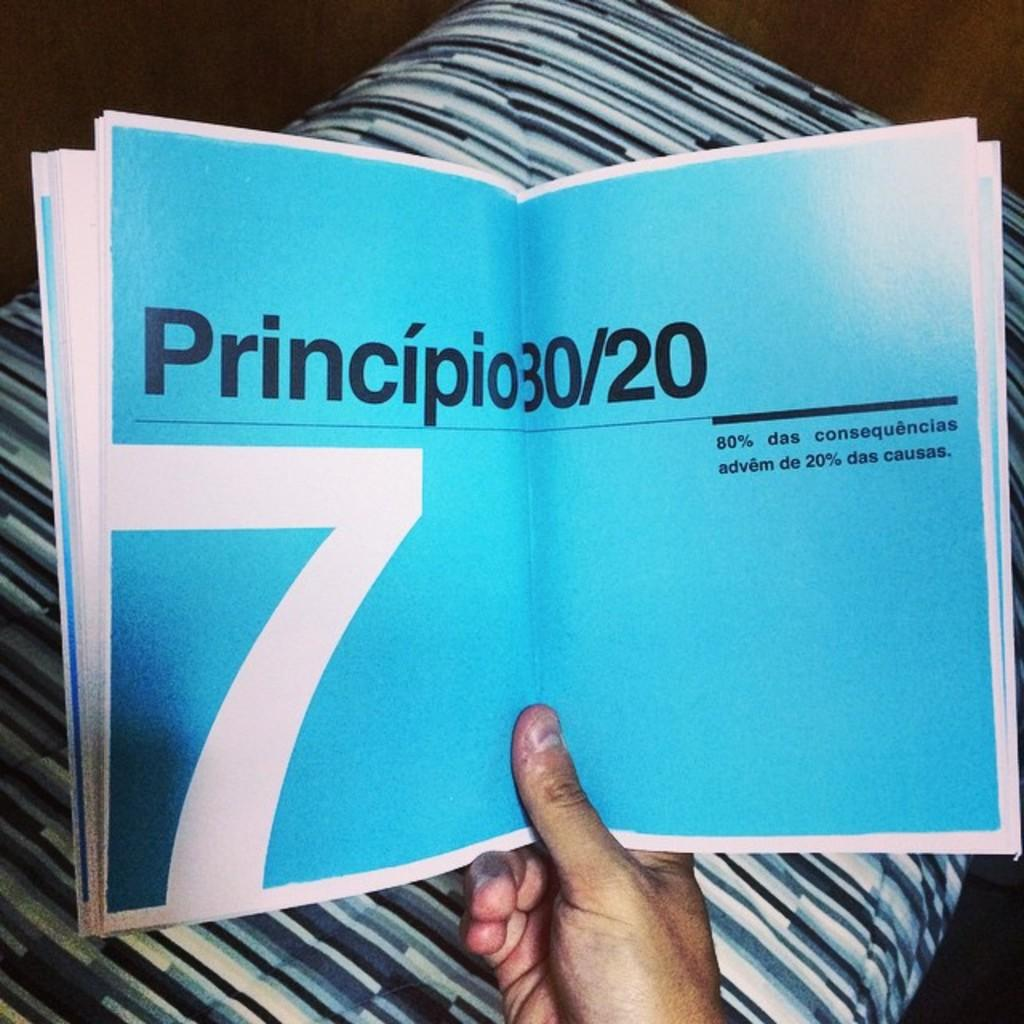<image>
Write a terse but informative summary of the picture. A book is opened to a page with a large seven on it. 